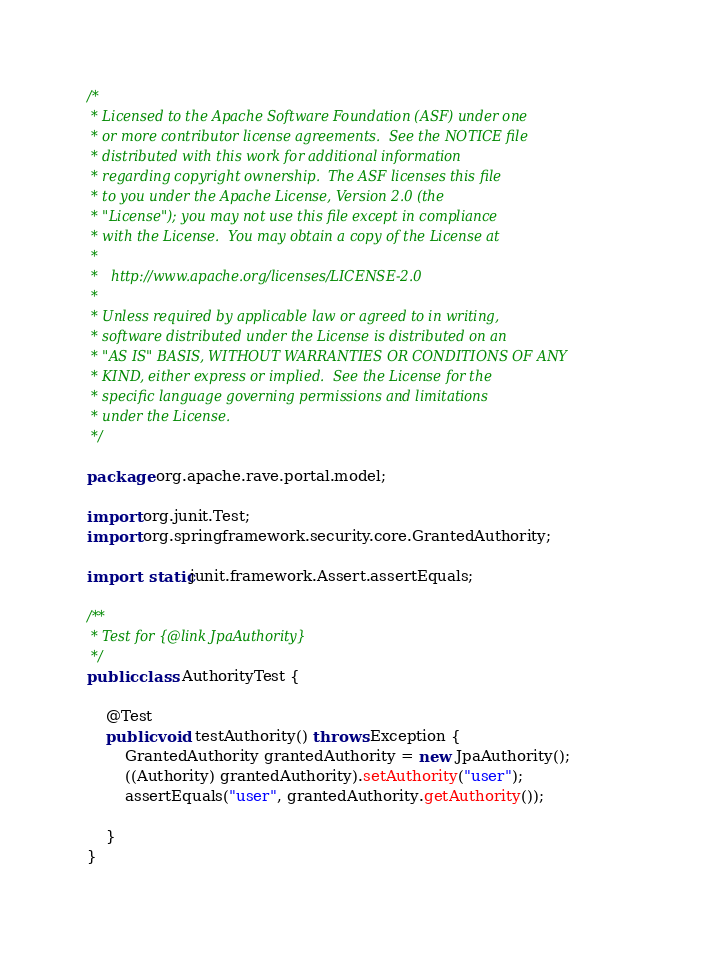Convert code to text. <code><loc_0><loc_0><loc_500><loc_500><_Java_>/*
 * Licensed to the Apache Software Foundation (ASF) under one
 * or more contributor license agreements.  See the NOTICE file
 * distributed with this work for additional information
 * regarding copyright ownership.  The ASF licenses this file
 * to you under the Apache License, Version 2.0 (the
 * "License"); you may not use this file except in compliance
 * with the License.  You may obtain a copy of the License at
 *
 *   http://www.apache.org/licenses/LICENSE-2.0
 *
 * Unless required by applicable law or agreed to in writing,
 * software distributed under the License is distributed on an
 * "AS IS" BASIS, WITHOUT WARRANTIES OR CONDITIONS OF ANY
 * KIND, either express or implied.  See the License for the
 * specific language governing permissions and limitations
 * under the License.
 */

package org.apache.rave.portal.model;

import org.junit.Test;
import org.springframework.security.core.GrantedAuthority;

import static junit.framework.Assert.assertEquals;

/**
 * Test for {@link JpaAuthority}
 */
public class AuthorityTest {

    @Test
    public void testAuthority() throws Exception {
        GrantedAuthority grantedAuthority = new JpaAuthority();
        ((Authority) grantedAuthority).setAuthority("user");
        assertEquals("user", grantedAuthority.getAuthority());

    }
}
</code> 